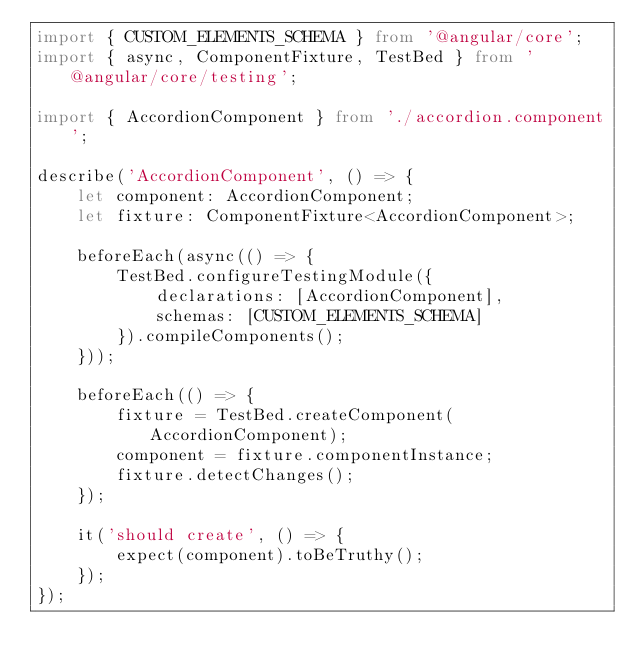Convert code to text. <code><loc_0><loc_0><loc_500><loc_500><_TypeScript_>import { CUSTOM_ELEMENTS_SCHEMA } from '@angular/core';
import { async, ComponentFixture, TestBed } from '@angular/core/testing';

import { AccordionComponent } from './accordion.component';

describe('AccordionComponent', () => {
	let component: AccordionComponent;
	let fixture: ComponentFixture<AccordionComponent>;

	beforeEach(async(() => {
		TestBed.configureTestingModule({
			declarations: [AccordionComponent],
			schemas: [CUSTOM_ELEMENTS_SCHEMA]
		}).compileComponents();
	}));

	beforeEach(() => {
		fixture = TestBed.createComponent(AccordionComponent);
		component = fixture.componentInstance;
		fixture.detectChanges();
	});

	it('should create', () => {
		expect(component).toBeTruthy();
	});
});
</code> 